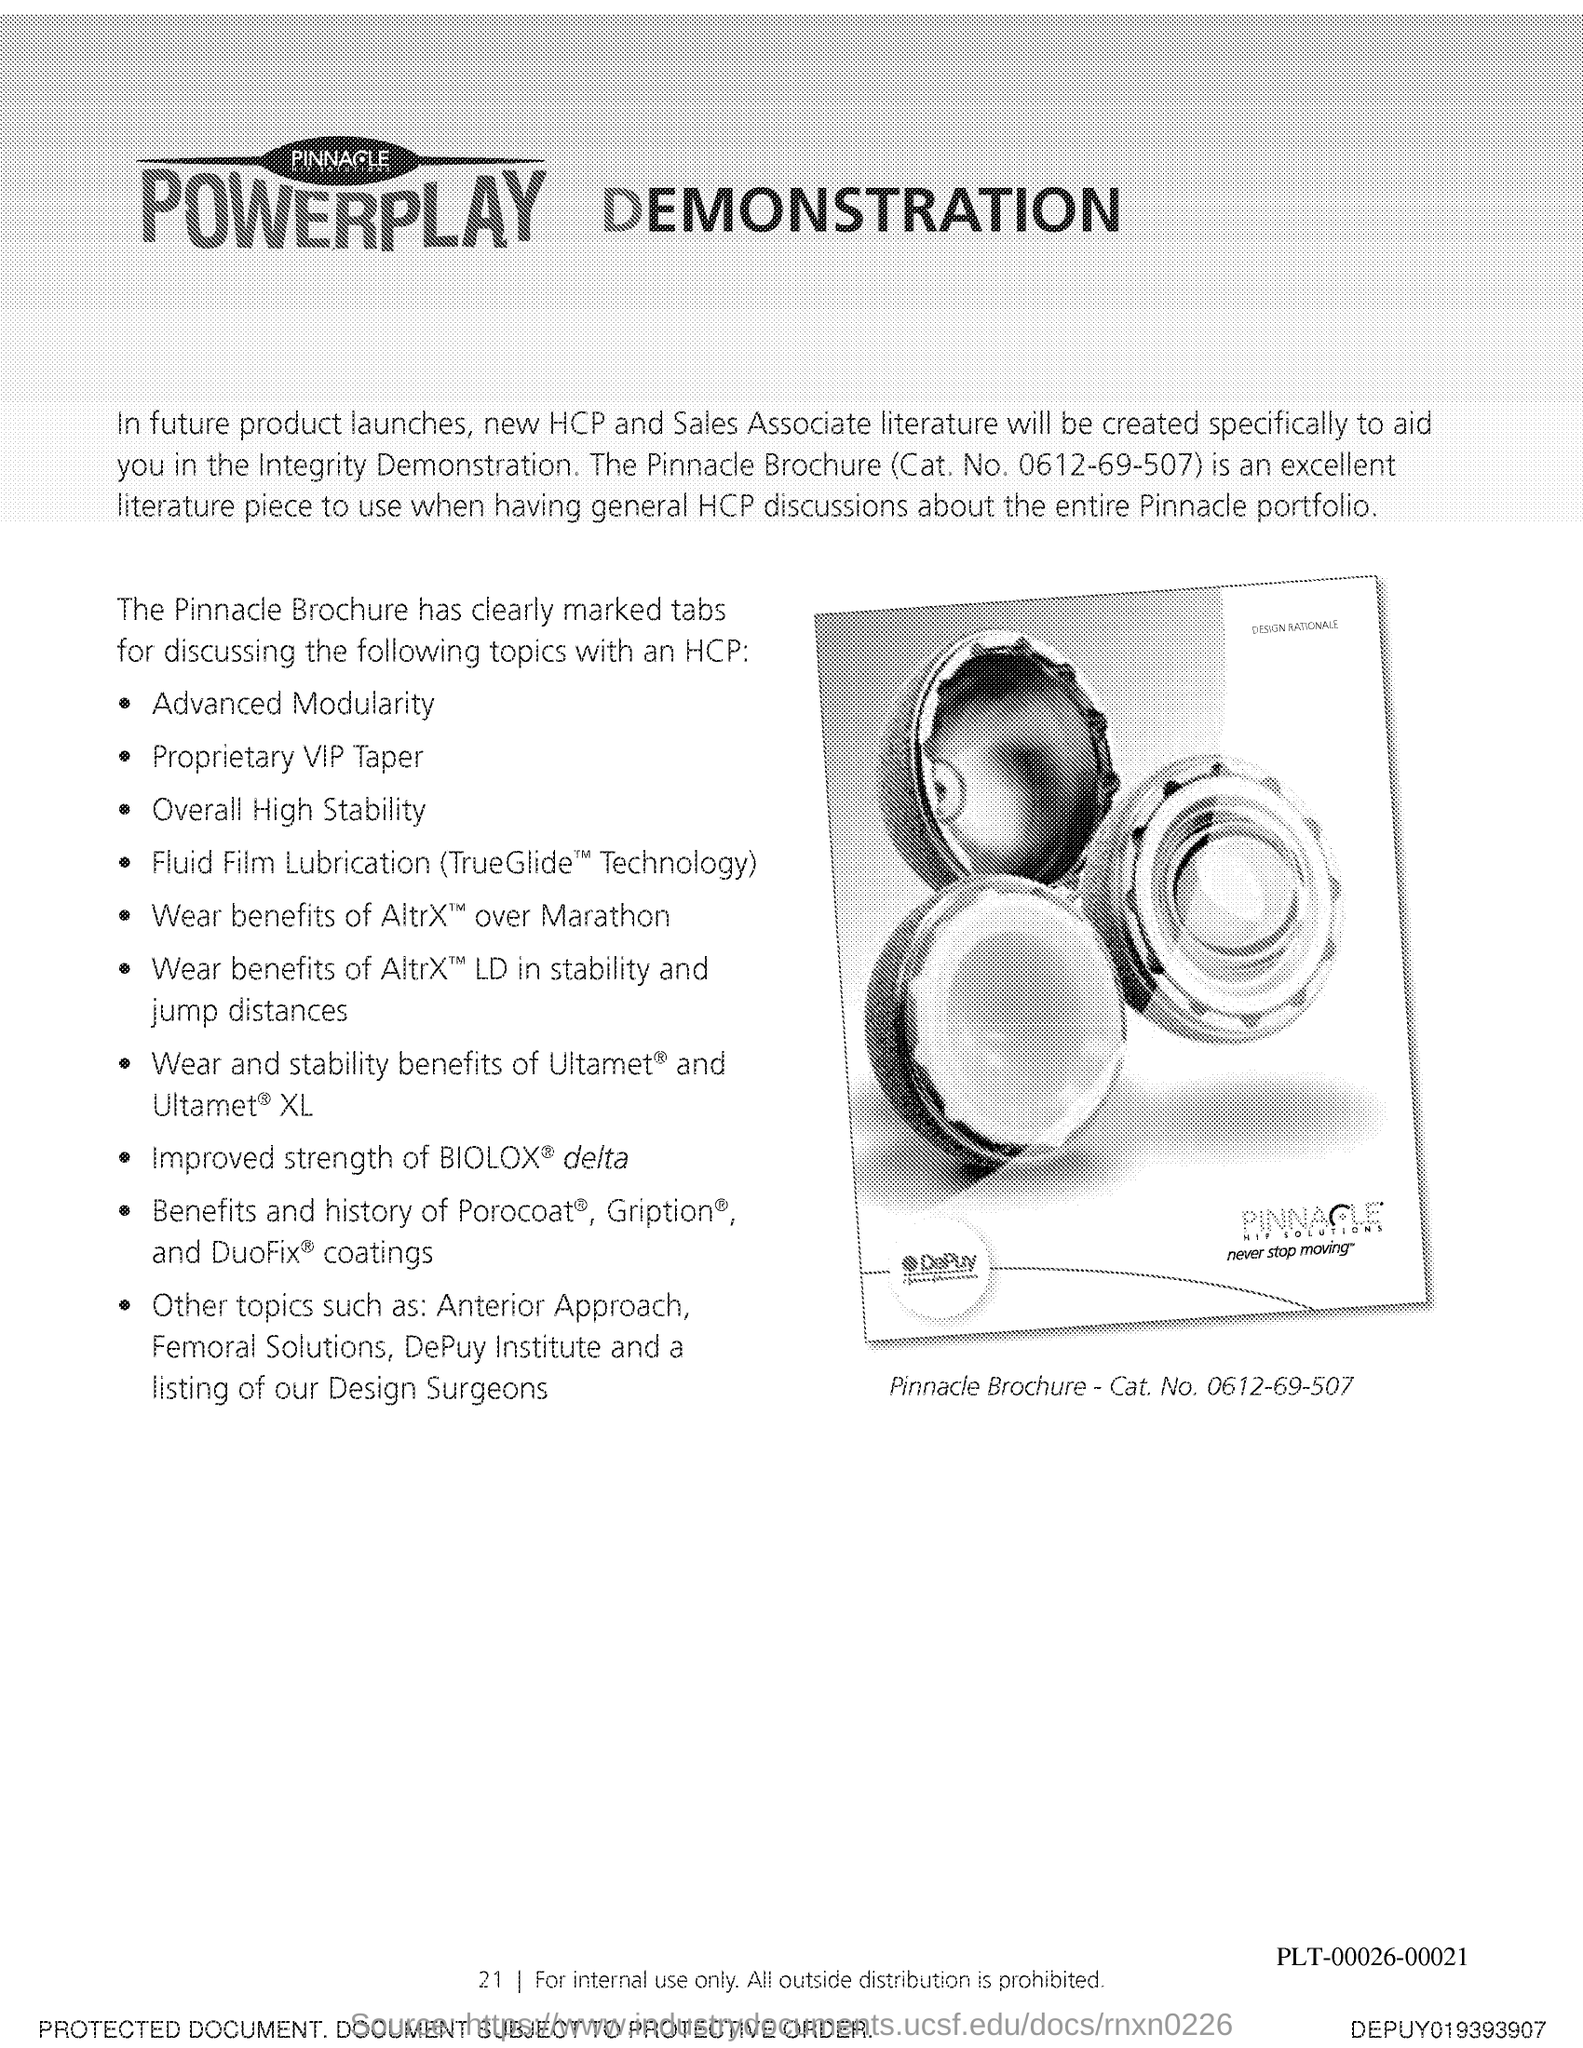Specify some key components in this picture. The page number is 21. 